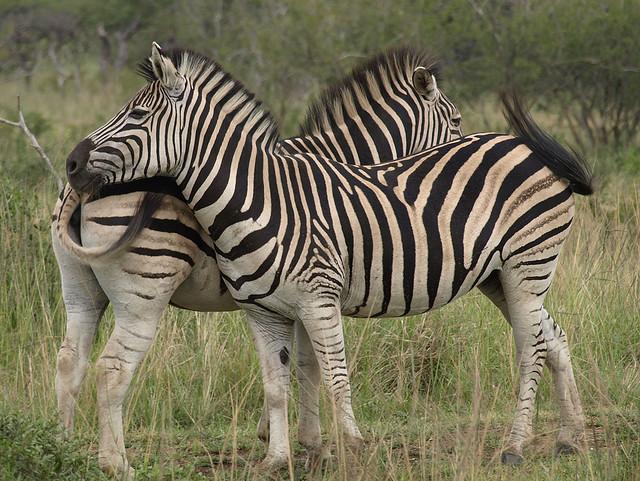How many zebra legs are in this scene?
Keep it brief. 8. How many animals are in this picture?
Quick response, please. 2. Do these animals live in herds?
Write a very short answer. Yes. Is there grass?
Write a very short answer. Yes. 